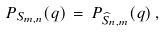<formula> <loc_0><loc_0><loc_500><loc_500>P _ { S _ { m , n } } ( q ) \, = \, P _ { \widehat { S } _ { n , m } } ( q ) \, ,</formula> 